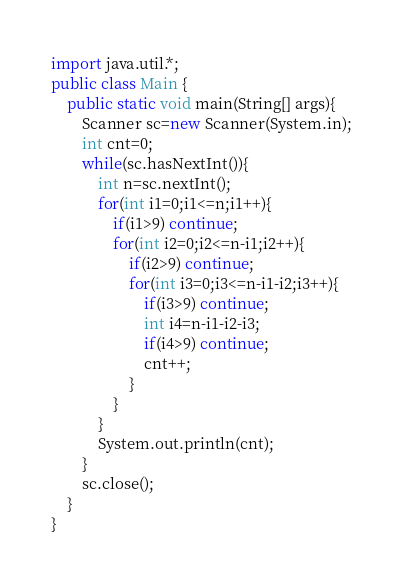<code> <loc_0><loc_0><loc_500><loc_500><_Java_>import java.util.*;
public class Main {
	public static void main(String[] args){
		Scanner sc=new Scanner(System.in);
		int cnt=0;
		while(sc.hasNextInt()){
			int n=sc.nextInt();
			for(int i1=0;i1<=n;i1++){
				if(i1>9) continue;
				for(int i2=0;i2<=n-i1;i2++){
					if(i2>9) continue;
					for(int i3=0;i3<=n-i1-i2;i3++){
						if(i3>9) continue;
						int i4=n-i1-i2-i3;
						if(i4>9) continue;
						cnt++;
					}
				}
			}
			System.out.println(cnt);
		}
		sc.close();
	}
}</code> 